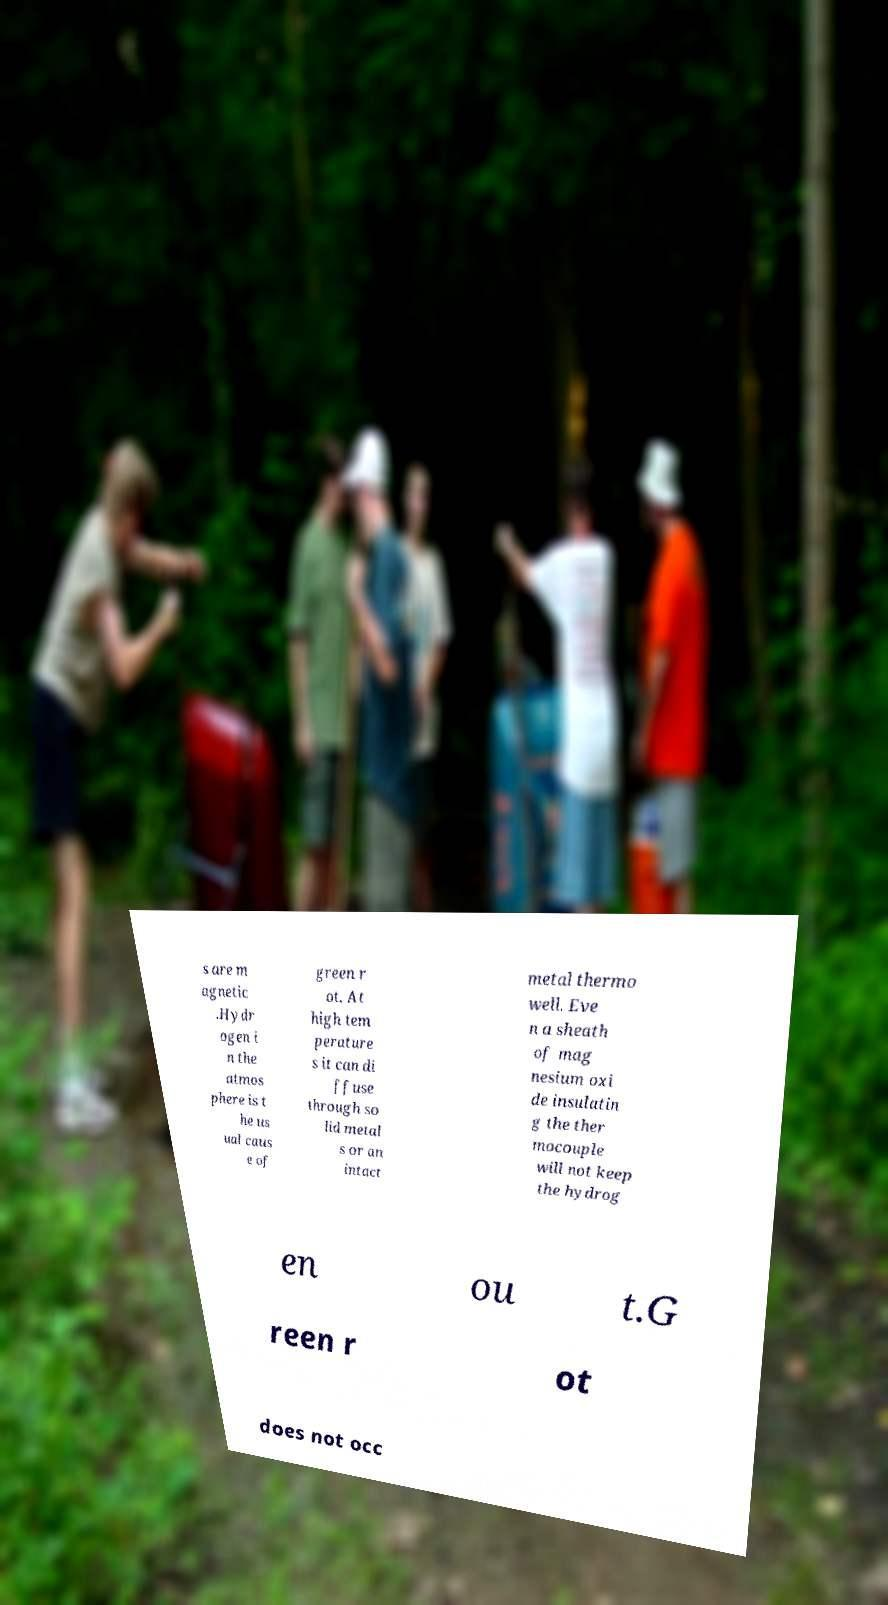Please read and relay the text visible in this image. What does it say? s are m agnetic .Hydr ogen i n the atmos phere is t he us ual caus e of green r ot. At high tem perature s it can di ffuse through so lid metal s or an intact metal thermo well. Eve n a sheath of mag nesium oxi de insulatin g the ther mocouple will not keep the hydrog en ou t.G reen r ot does not occ 